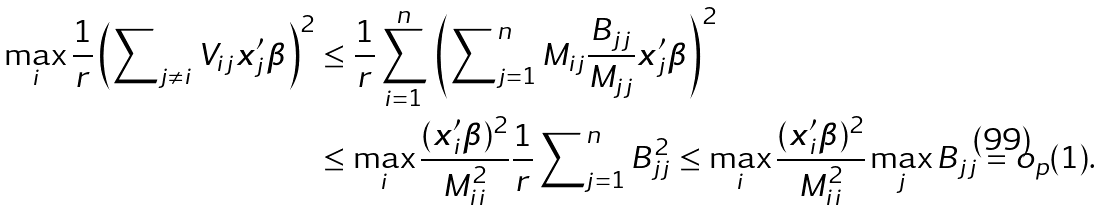Convert formula to latex. <formula><loc_0><loc_0><loc_500><loc_500>\max _ { i } \frac { 1 } { r } \left ( \sum \nolimits _ { j \neq i } V _ { i j } { \boldsymbol x } _ { j } ^ { \prime } { \boldsymbol \beta } \right ) ^ { 2 } & \leq \frac { 1 } { r } \sum _ { i = 1 } ^ { n } \, \left ( \sum \nolimits _ { j = 1 } ^ { n } M _ { i j } \frac { B _ { j j } } { M _ { j j } } { \boldsymbol x } _ { j } ^ { \prime } { \boldsymbol \beta } \right ) ^ { 2 } \\ & \leq \max _ { i } \frac { ( { \boldsymbol x } _ { i } ^ { \prime } { \boldsymbol \beta } ) ^ { 2 } } { M _ { i i } ^ { 2 } } \frac { 1 } { r } \sum \nolimits _ { j = 1 } ^ { n } B _ { j j } ^ { 2 } \leq \max _ { i } \frac { ( { \boldsymbol x } _ { i } ^ { \prime } { \boldsymbol \beta } ) ^ { 2 } } { M _ { i i } ^ { 2 } } \max _ { j } B _ { j j } = o _ { p } ( 1 ) .</formula> 